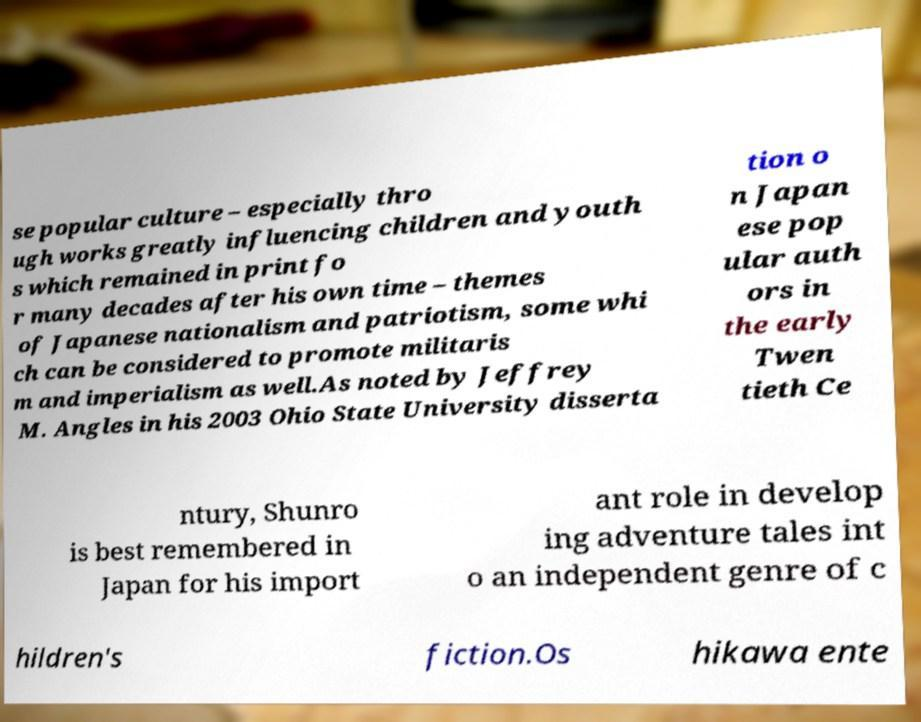Please identify and transcribe the text found in this image. se popular culture – especially thro ugh works greatly influencing children and youth s which remained in print fo r many decades after his own time – themes of Japanese nationalism and patriotism, some whi ch can be considered to promote militaris m and imperialism as well.As noted by Jeffrey M. Angles in his 2003 Ohio State University disserta tion o n Japan ese pop ular auth ors in the early Twen tieth Ce ntury, Shunro is best remembered in Japan for his import ant role in develop ing adventure tales int o an independent genre of c hildren's fiction.Os hikawa ente 